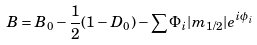<formula> <loc_0><loc_0><loc_500><loc_500>B = B _ { 0 } - \frac { 1 } { 2 } ( 1 - D _ { 0 } ) - \sum \Phi _ { i } | m _ { 1 / 2 } | e ^ { i \phi _ { i } }</formula> 